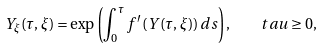<formula> <loc_0><loc_0><loc_500><loc_500>{ Y } _ { \xi } ( \tau , \xi ) = \exp \left ( \int _ { 0 } ^ { \tau } f ^ { \prime } \left ( Y ( \tau , \xi ) \right ) d s \right ) , \quad t a u \geq 0 ,</formula> 